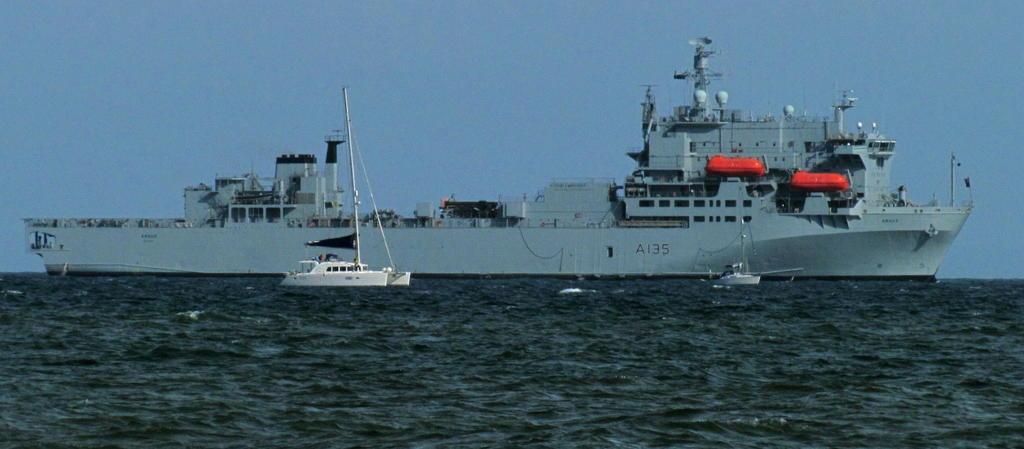Is this a us navy ship?
Offer a terse response. Yes. What is on the side of the ship?
Offer a very short reply. A135. 